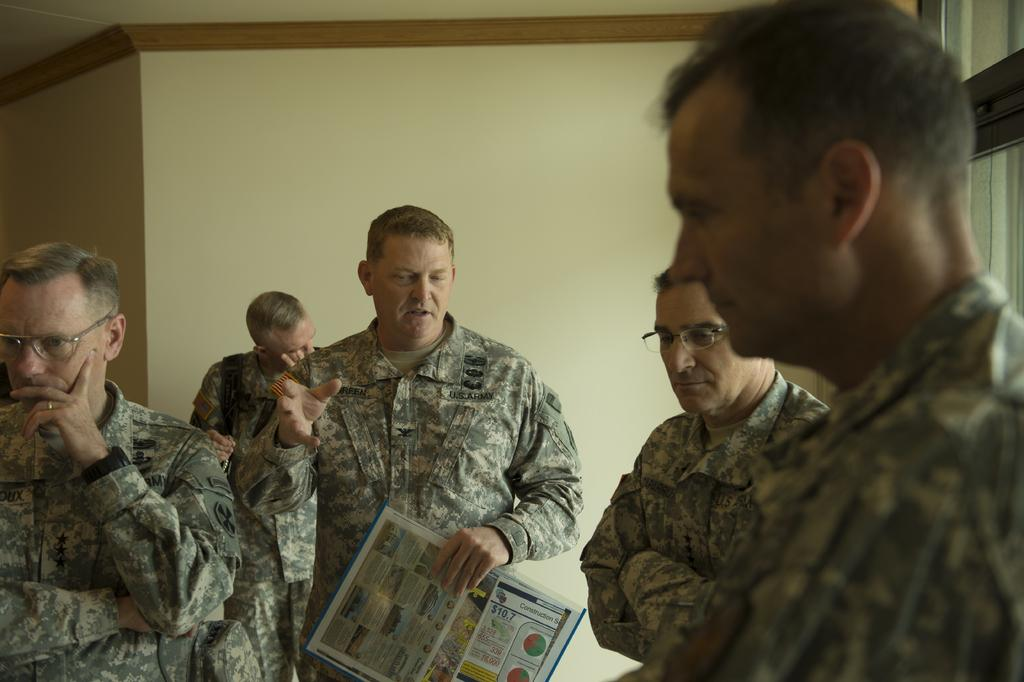Who is the main subject in the image? There is a man in the middle of the image. What is the central man doing? The man is speaking. Are there any other people in the image? Yes, there are other men around the central man. What are the men wearing? The men are wearing army dresses. What type of bone can be seen in the image? There is no bone present in the image. How many cattle are visible in the image? There are no cattle present in the image. 